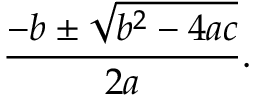<formula> <loc_0><loc_0><loc_500><loc_500>{ \frac { - b \pm { \sqrt { b ^ { 2 } - 4 a c } } } { 2 a } } .</formula> 